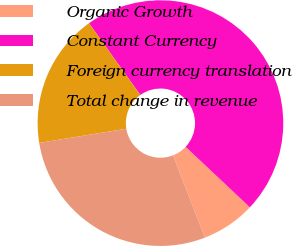Convert chart. <chart><loc_0><loc_0><loc_500><loc_500><pie_chart><fcel>Organic Growth<fcel>Constant Currency<fcel>Foreign currency translation<fcel>Total change in revenue<nl><fcel>7.08%<fcel>46.9%<fcel>17.7%<fcel>28.32%<nl></chart> 